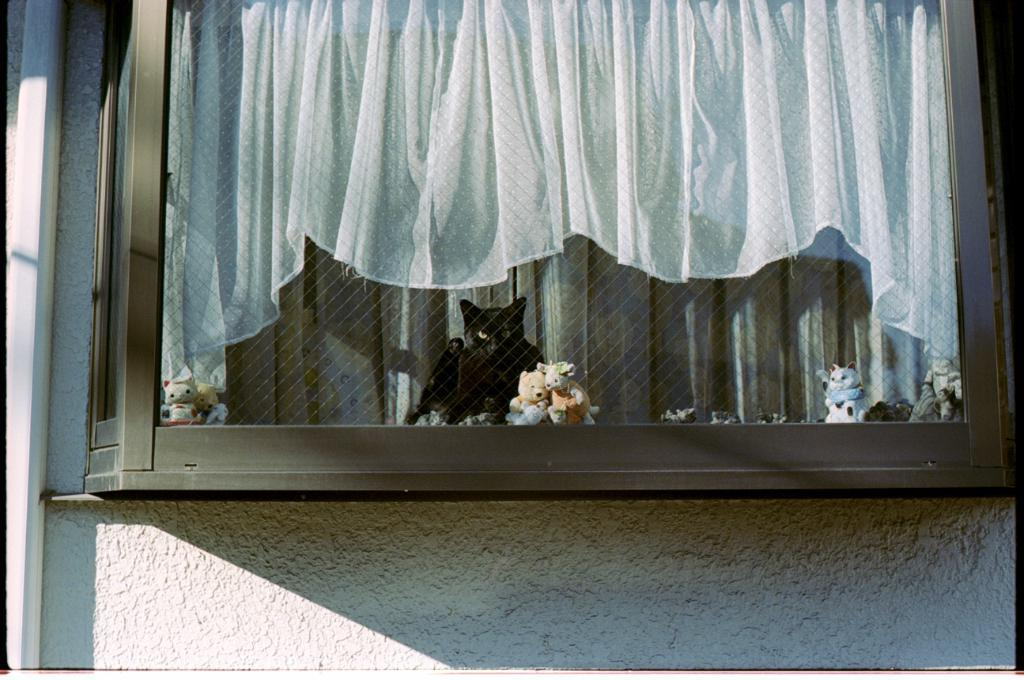What types of objects can be seen in the image? There are toys in multi color and a cat in black color in the image. What color is the curtain in the background of the image? The curtain in the background of the image is in white color. What color is the wall in the background of the image? The wall in the background of the image is in white color. What type of leaf can be seen falling from the ceiling in the image? There is no leaf present in the image; it features toys, a cat, a curtain, and a wall. 